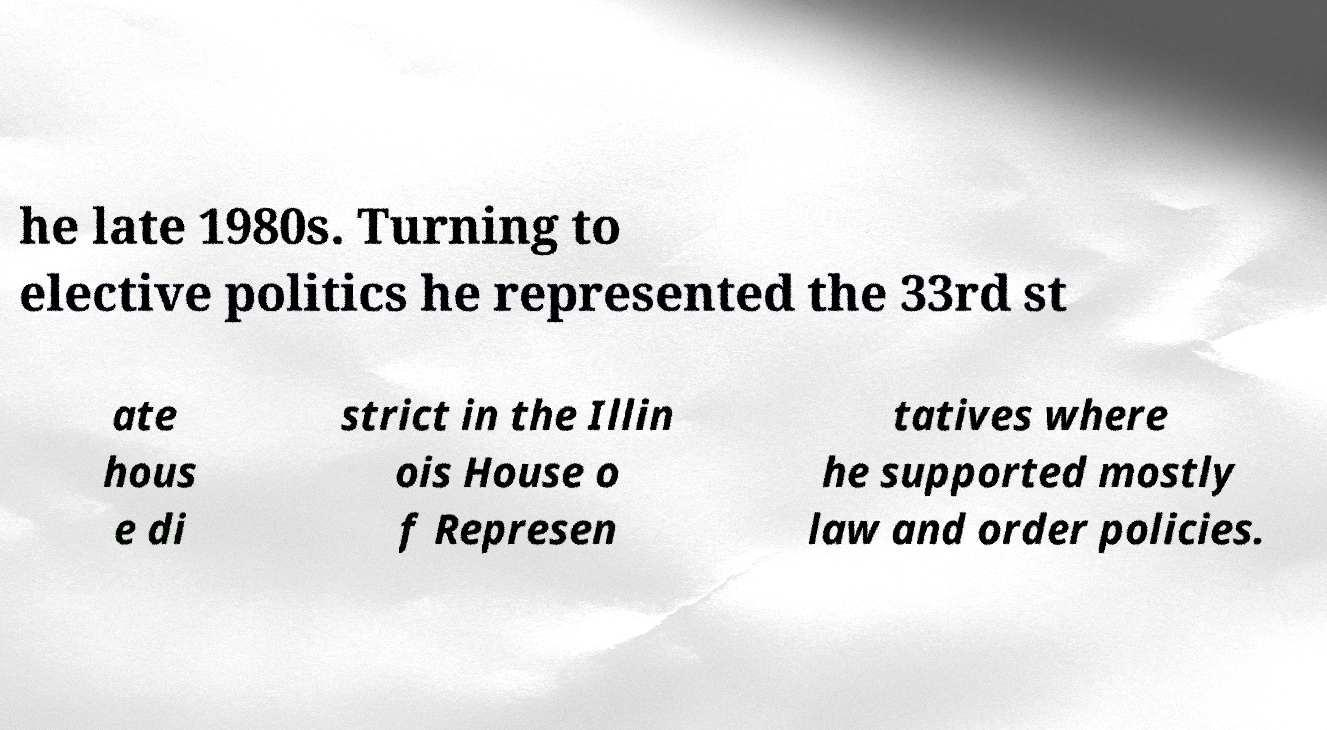Please read and relay the text visible in this image. What does it say? he late 1980s. Turning to elective politics he represented the 33rd st ate hous e di strict in the Illin ois House o f Represen tatives where he supported mostly law and order policies. 